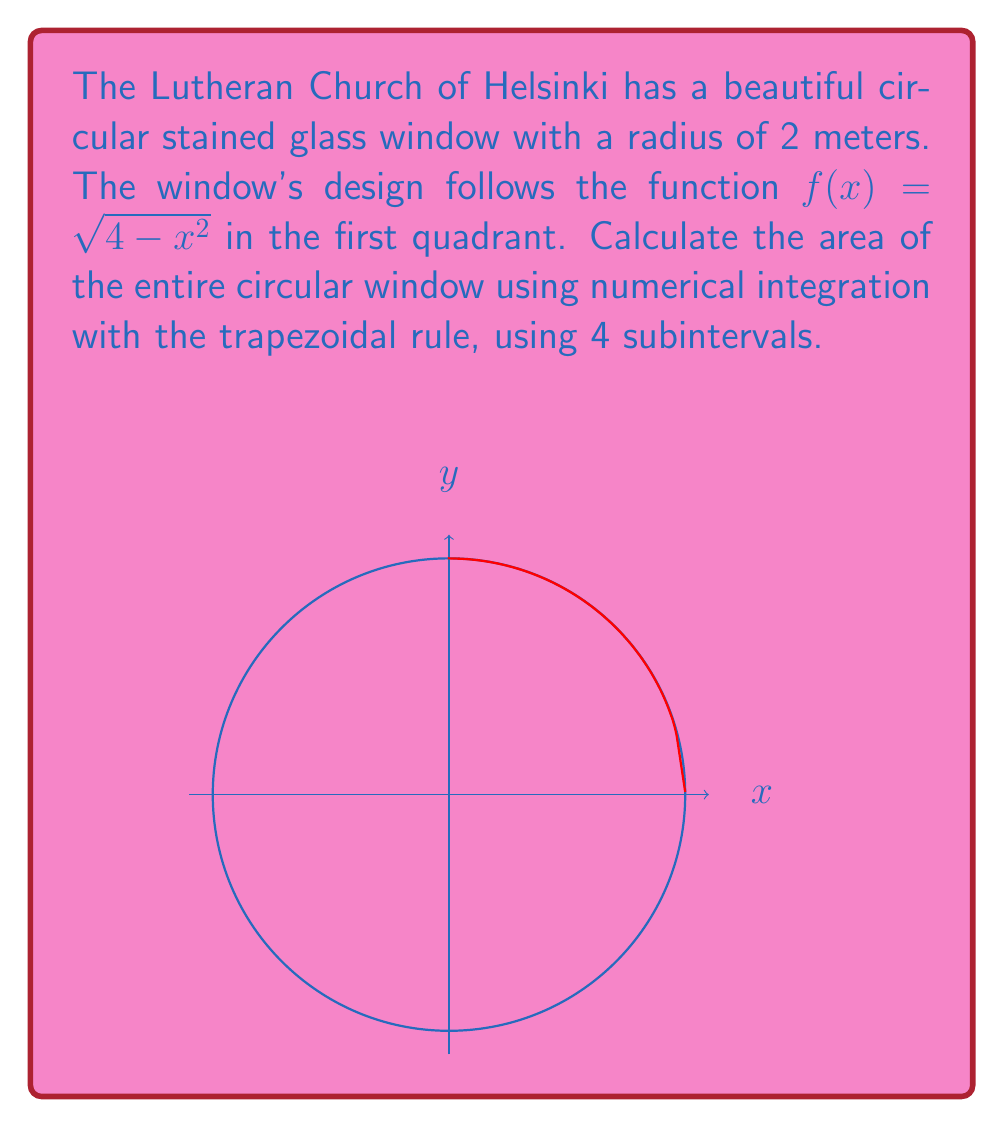Could you help me with this problem? Let's approach this step-by-step:

1) The function $f(x) = \sqrt{4 - x^2}$ represents a quarter of the circle in the first quadrant.

2) To find the area of the entire circle, we need to integrate this function over [0, 2] and multiply the result by 4.

3) The trapezoidal rule with n subintervals is given by:

   $$\int_a^b f(x)dx \approx \frac{h}{2}[f(x_0) + 2f(x_1) + 2f(x_2) + ... + 2f(x_{n-1}) + f(x_n)]$$

   where $h = \frac{b-a}{n}$ and $x_i = a + ih$ for $i = 0, 1, ..., n$

4) In our case, $a=0$, $b=2$, and $n=4$. So, $h = \frac{2-0}{4} = 0.5$

5) We need to calculate $f(x)$ at $x = 0, 0.5, 1, 1.5, 2$:

   $f(0) = 2$
   $f(0.5) = \sqrt{4 - 0.5^2} = \sqrt{3.75} \approx 1.9365$
   $f(1) = \sqrt{4 - 1^2} = \sqrt{3} \approx 1.7321$
   $f(1.5) = \sqrt{4 - 1.5^2} = \sqrt{1.75} \approx 1.3229$
   $f(2) = \sqrt{4 - 2^2} = 0$

6) Applying the trapezoidal rule:

   $$\text{Area} \approx 4 \cdot \frac{0.5}{2}[2 + 2(1.9365) + 2(1.7321) + 2(1.3229) + 0]$$
   $$= 2[2 + 3.8730 + 3.4642 + 2.6458]$$
   $$= 2[11.9830] = 23.9660$$

7) The exact area of a circle with radius 2 is $4\pi \approx 12.5664$, so our approximation has some error due to the low number of subintervals.
Answer: $23.9660 \text{ square meters}$ 